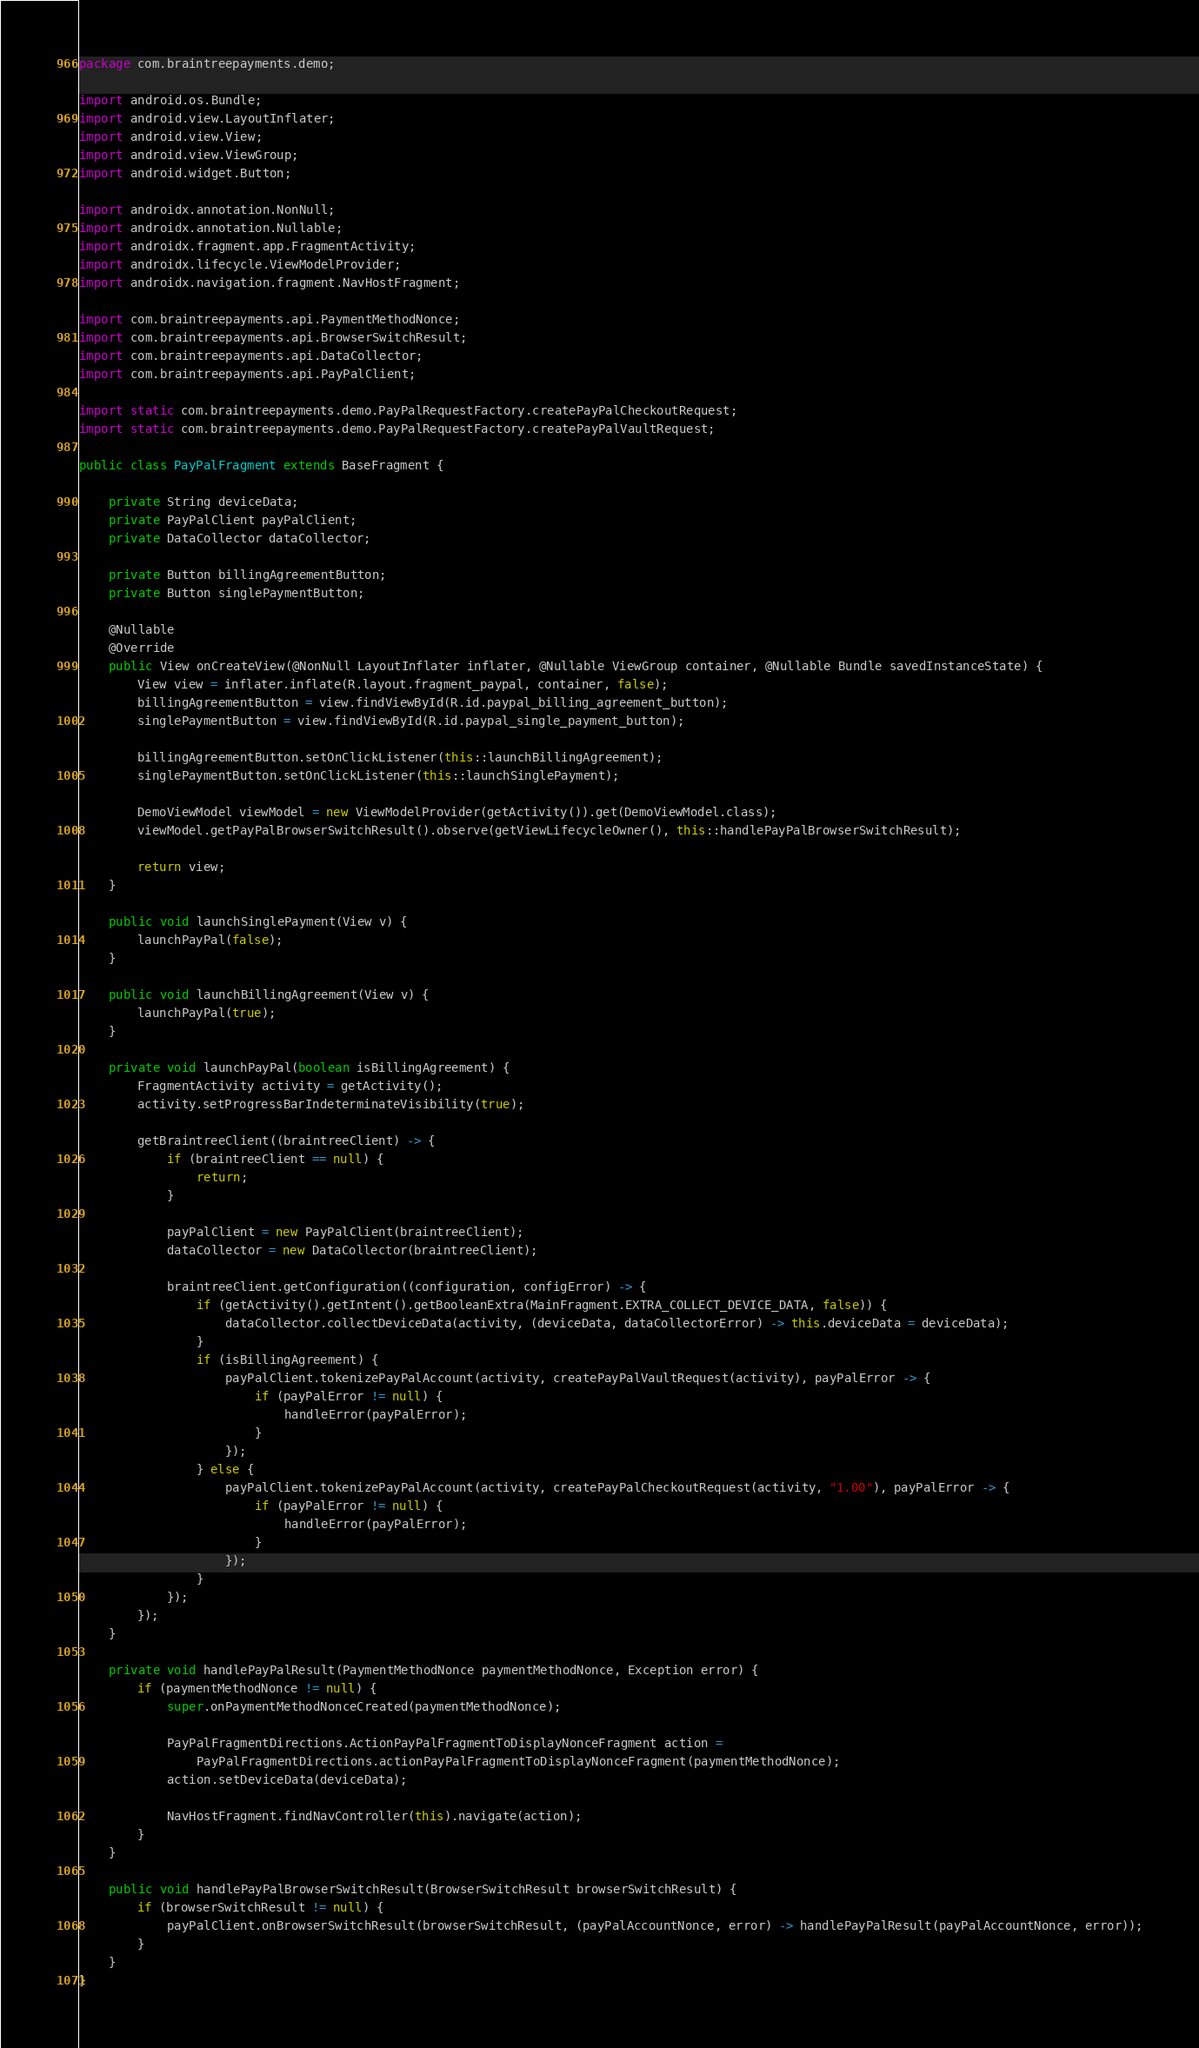Convert code to text. <code><loc_0><loc_0><loc_500><loc_500><_Java_>package com.braintreepayments.demo;

import android.os.Bundle;
import android.view.LayoutInflater;
import android.view.View;
import android.view.ViewGroup;
import android.widget.Button;

import androidx.annotation.NonNull;
import androidx.annotation.Nullable;
import androidx.fragment.app.FragmentActivity;
import androidx.lifecycle.ViewModelProvider;
import androidx.navigation.fragment.NavHostFragment;

import com.braintreepayments.api.PaymentMethodNonce;
import com.braintreepayments.api.BrowserSwitchResult;
import com.braintreepayments.api.DataCollector;
import com.braintreepayments.api.PayPalClient;

import static com.braintreepayments.demo.PayPalRequestFactory.createPayPalCheckoutRequest;
import static com.braintreepayments.demo.PayPalRequestFactory.createPayPalVaultRequest;

public class PayPalFragment extends BaseFragment {

    private String deviceData;
    private PayPalClient payPalClient;
    private DataCollector dataCollector;

    private Button billingAgreementButton;
    private Button singlePaymentButton;

    @Nullable
    @Override
    public View onCreateView(@NonNull LayoutInflater inflater, @Nullable ViewGroup container, @Nullable Bundle savedInstanceState) {
        View view = inflater.inflate(R.layout.fragment_paypal, container, false);
        billingAgreementButton = view.findViewById(R.id.paypal_billing_agreement_button);
        singlePaymentButton = view.findViewById(R.id.paypal_single_payment_button);

        billingAgreementButton.setOnClickListener(this::launchBillingAgreement);
        singlePaymentButton.setOnClickListener(this::launchSinglePayment);

        DemoViewModel viewModel = new ViewModelProvider(getActivity()).get(DemoViewModel.class);
        viewModel.getPayPalBrowserSwitchResult().observe(getViewLifecycleOwner(), this::handlePayPalBrowserSwitchResult);

        return view;
    }

    public void launchSinglePayment(View v) {
        launchPayPal(false);
    }

    public void launchBillingAgreement(View v) {
        launchPayPal(true);
    }

    private void launchPayPal(boolean isBillingAgreement) {
        FragmentActivity activity = getActivity();
        activity.setProgressBarIndeterminateVisibility(true);

        getBraintreeClient((braintreeClient) -> {
            if (braintreeClient == null) {
                return;
            }

            payPalClient = new PayPalClient(braintreeClient);
            dataCollector = new DataCollector(braintreeClient);

            braintreeClient.getConfiguration((configuration, configError) -> {
                if (getActivity().getIntent().getBooleanExtra(MainFragment.EXTRA_COLLECT_DEVICE_DATA, false)) {
                    dataCollector.collectDeviceData(activity, (deviceData, dataCollectorError) -> this.deviceData = deviceData);
                }
                if (isBillingAgreement) {
                    payPalClient.tokenizePayPalAccount(activity, createPayPalVaultRequest(activity), payPalError -> {
                        if (payPalError != null) {
                            handleError(payPalError);
                        }
                    });
                } else {
                    payPalClient.tokenizePayPalAccount(activity, createPayPalCheckoutRequest(activity, "1.00"), payPalError -> {
                        if (payPalError != null) {
                            handleError(payPalError);
                        }
                    });
                }
            });
        });
    }

    private void handlePayPalResult(PaymentMethodNonce paymentMethodNonce, Exception error) {
        if (paymentMethodNonce != null) {
            super.onPaymentMethodNonceCreated(paymentMethodNonce);

            PayPalFragmentDirections.ActionPayPalFragmentToDisplayNonceFragment action =
                PayPalFragmentDirections.actionPayPalFragmentToDisplayNonceFragment(paymentMethodNonce);
            action.setDeviceData(deviceData);

            NavHostFragment.findNavController(this).navigate(action);
        }
    }

    public void handlePayPalBrowserSwitchResult(BrowserSwitchResult browserSwitchResult) {
        if (browserSwitchResult != null) {
            payPalClient.onBrowserSwitchResult(browserSwitchResult, (payPalAccountNonce, error) -> handlePayPalResult(payPalAccountNonce, error));
        }
    }
}
</code> 